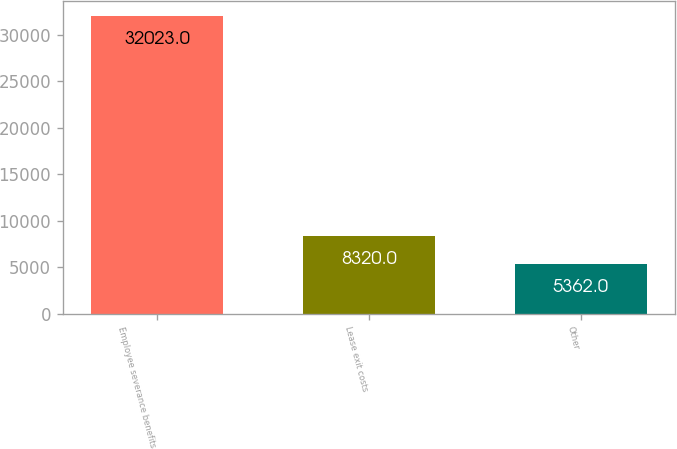Convert chart. <chart><loc_0><loc_0><loc_500><loc_500><bar_chart><fcel>Employee severance benefits<fcel>Lease exit costs<fcel>Other<nl><fcel>32023<fcel>8320<fcel>5362<nl></chart> 